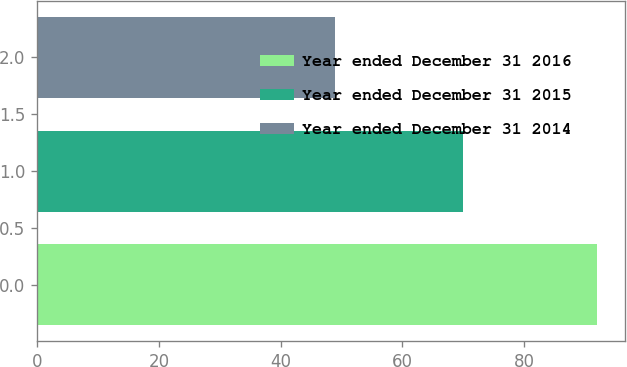Convert chart to OTSL. <chart><loc_0><loc_0><loc_500><loc_500><bar_chart><fcel>Year ended December 31 2016<fcel>Year ended December 31 2015<fcel>Year ended December 31 2014<nl><fcel>92<fcel>70<fcel>49<nl></chart> 